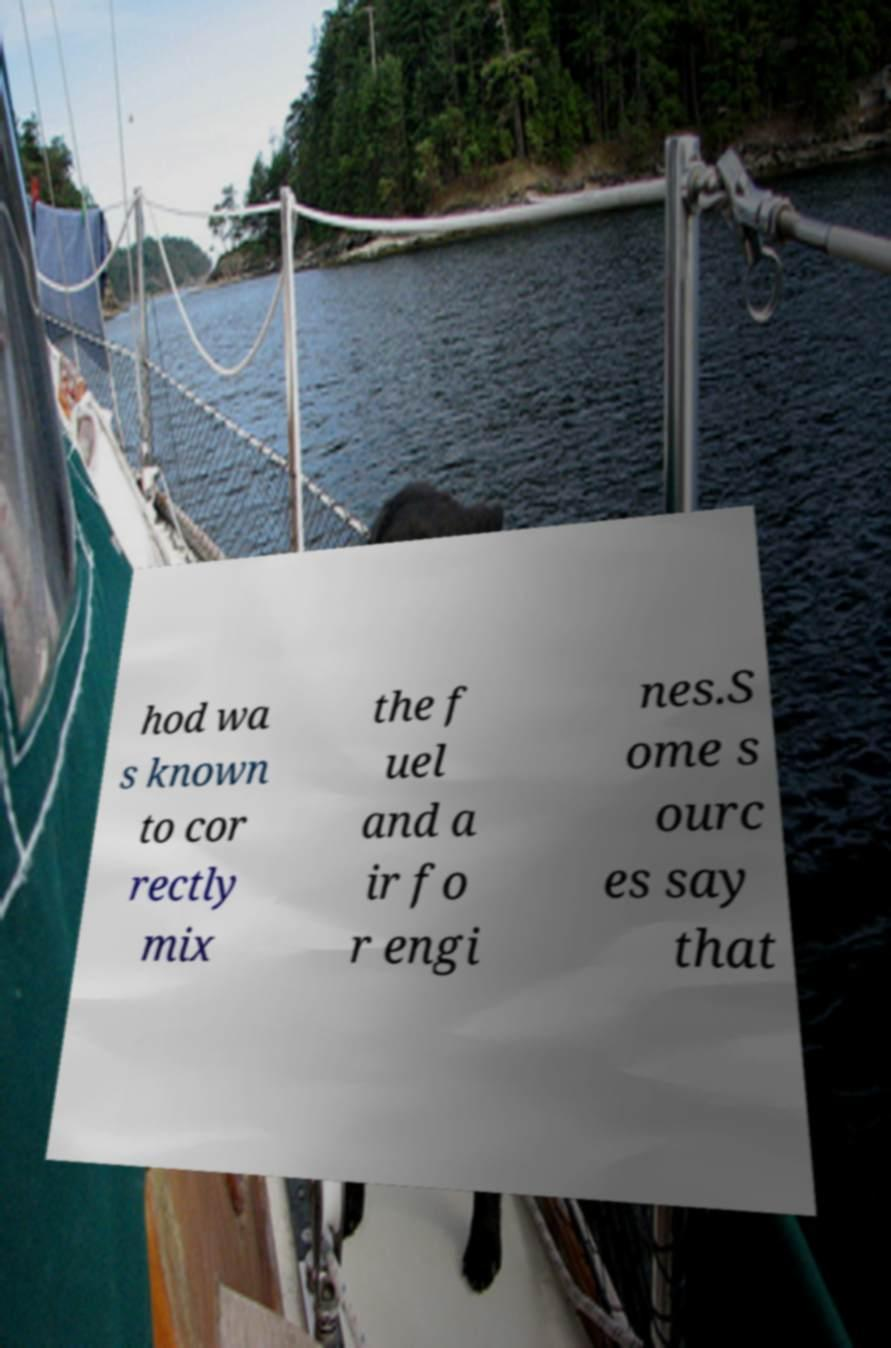I need the written content from this picture converted into text. Can you do that? hod wa s known to cor rectly mix the f uel and a ir fo r engi nes.S ome s ourc es say that 